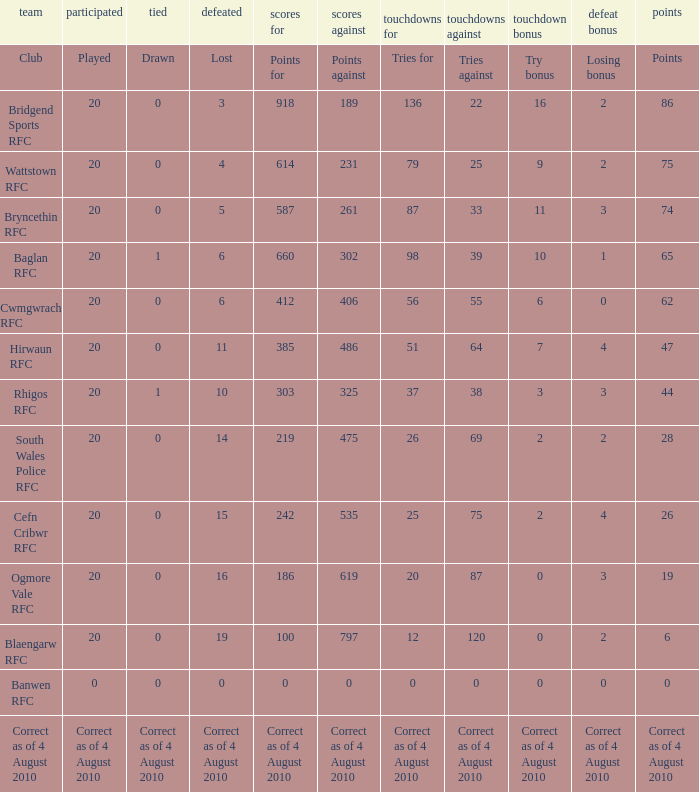What are the objections against when depicted is portrayed? Points against. 